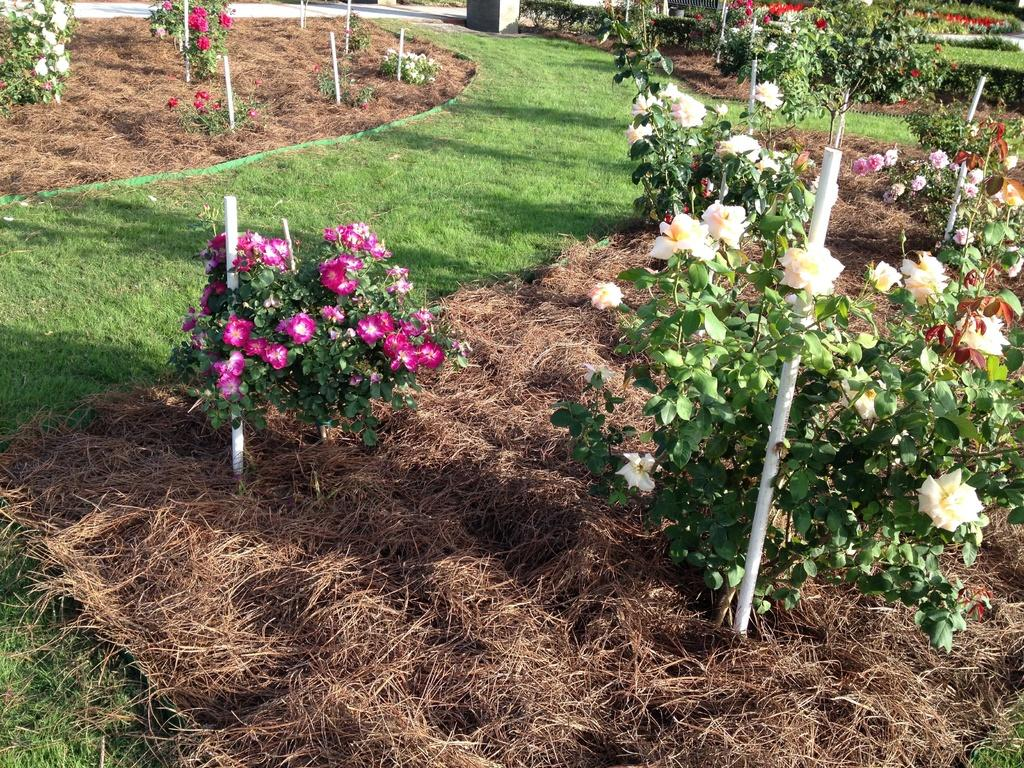What type of outdoor space is depicted in the image? There is a garden in the image. What can be found within the garden? There are flower trees in the garden. Reasoning: Let's think step by step by step in order to produce the conversation. We start by identifying the main subject of the image, which is the garden. Then, we describe the specific features of the garden, focusing on the presence of flower trees. Each question is designed to elicit a specific detail about the image that is known from the provided facts. Absurd Question/Answer: How many needles are attached to the flower trees in the image? There is no mention of needles in the image, as it features a garden with flower trees. 